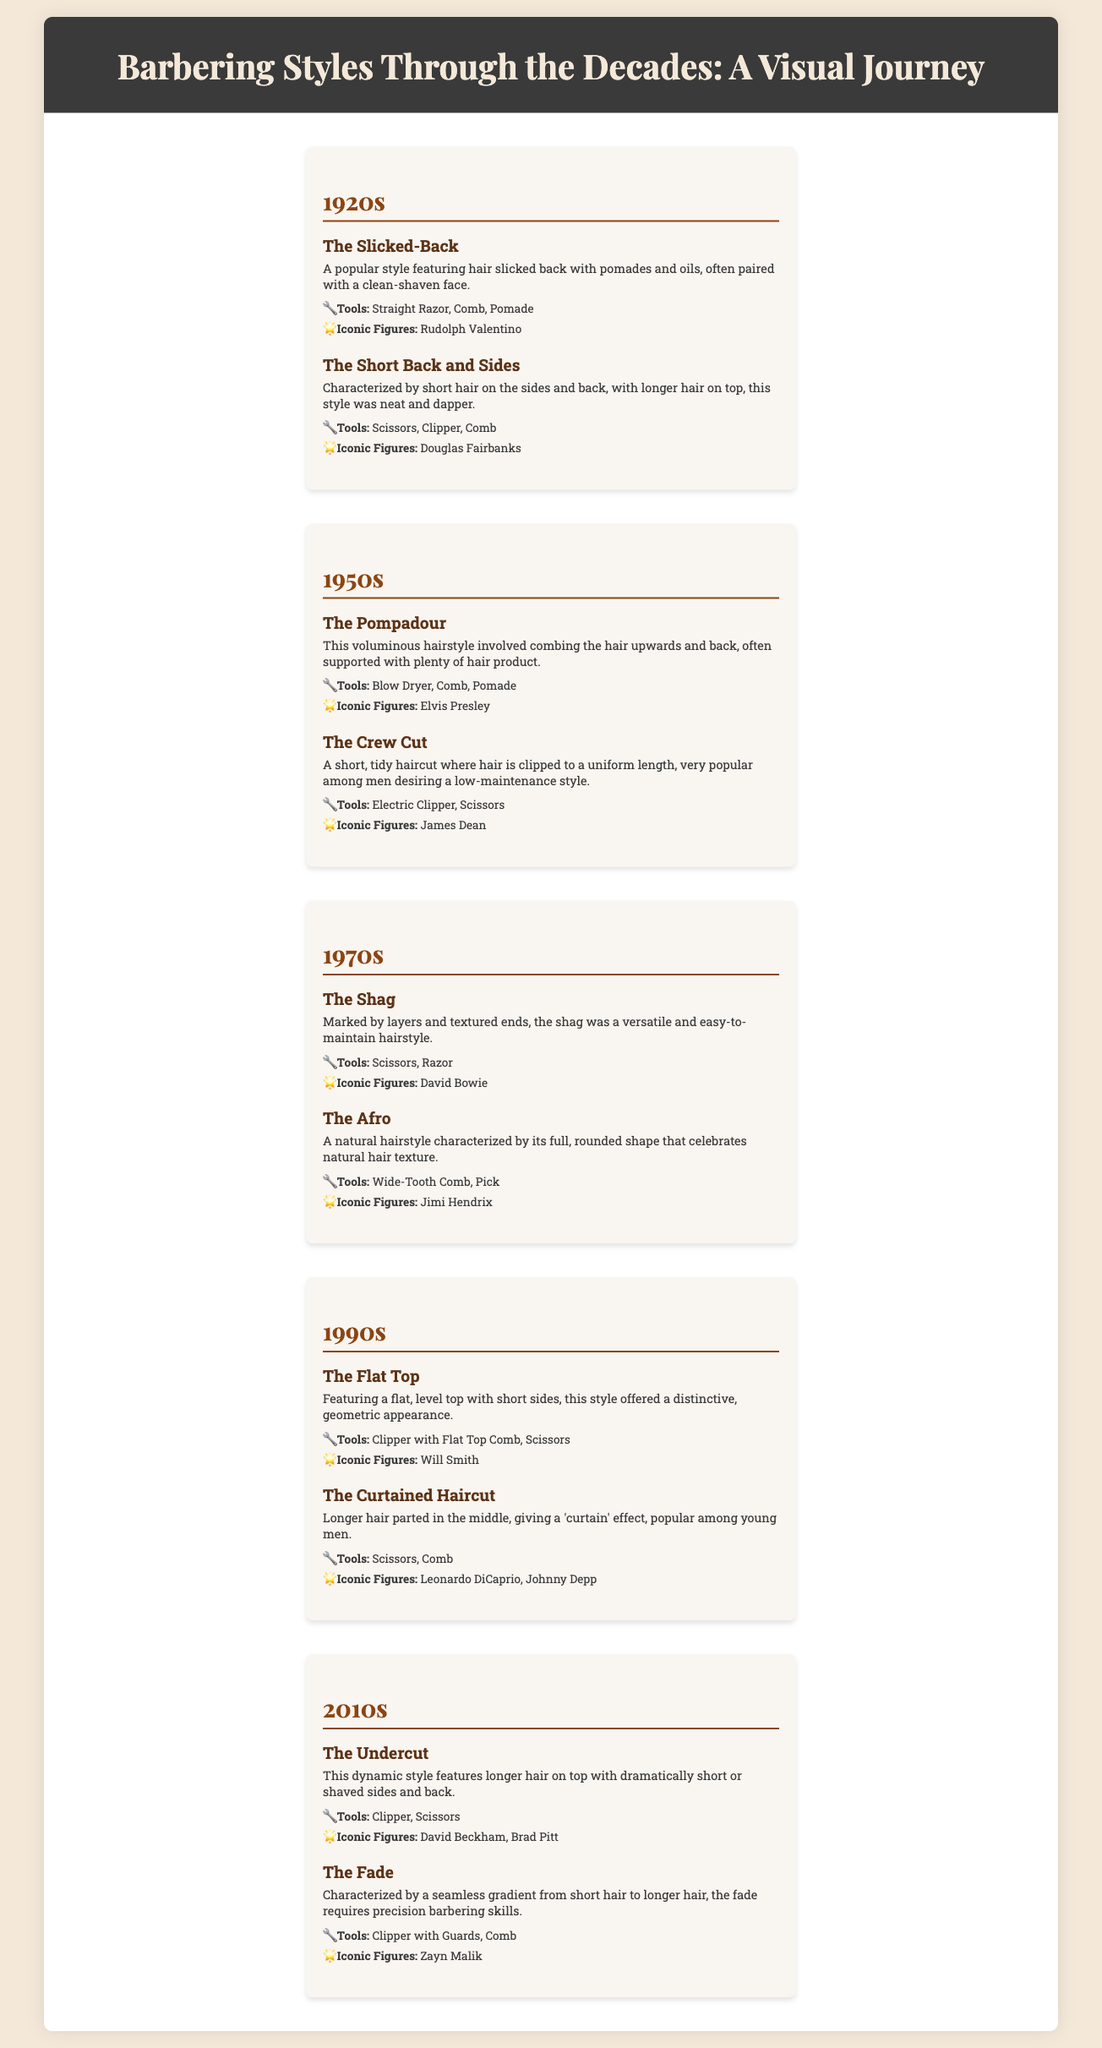What is the iconic figure of the 1920s style "The Slicked-Back"? The 1920s style "The Slicked-Back" features Rudolph Valentino as its iconic figure.
Answer: Rudolph Valentino What tools are used for "The Pompadour" hairstyle? "The Pompadour" hairstyle utilizes a blow dryer, comb, and pomade as main tools.
Answer: Blow Dryer, Comb, Pomade Which decade is associated with "The Afro" hairstyle? "The Afro" hairstyle is prominently featured in the 1970s section of the document.
Answer: 1970s What is the main characteristic of "The Fade"? "The Fade" is characterized by a seamless gradient from short hair to longer hair, showcasing precision barbering skills.
Answer: Seamless gradient Who is the iconic figure of "The Crew Cut"? The iconic figure associated with "The Crew Cut" is James Dean, who popularized this hairstyle.
Answer: James Dean How many styles are listed for the 2010s? The document lists two hairstyles for the 2010s decade.
Answer: 2 What style is described as featuring hair slicked back with pomades and oils? The style described as featuring hair slicked back with pomades and oils is known as "The Slicked-Back."
Answer: The Slicked-Back Which decades feature hairstyles related to David Bowie? David Bowie is featured in connection with the hairstyle "The Shag," which belongs to the 1970s.
Answer: 1970s 